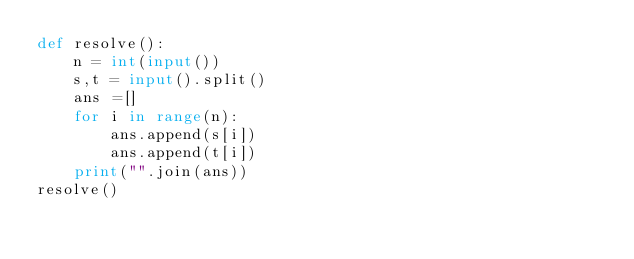<code> <loc_0><loc_0><loc_500><loc_500><_Python_>def resolve():
    n = int(input())
    s,t = input().split()
    ans =[]
    for i in range(n):
        ans.append(s[i])
        ans.append(t[i])
    print("".join(ans))
resolve()</code> 